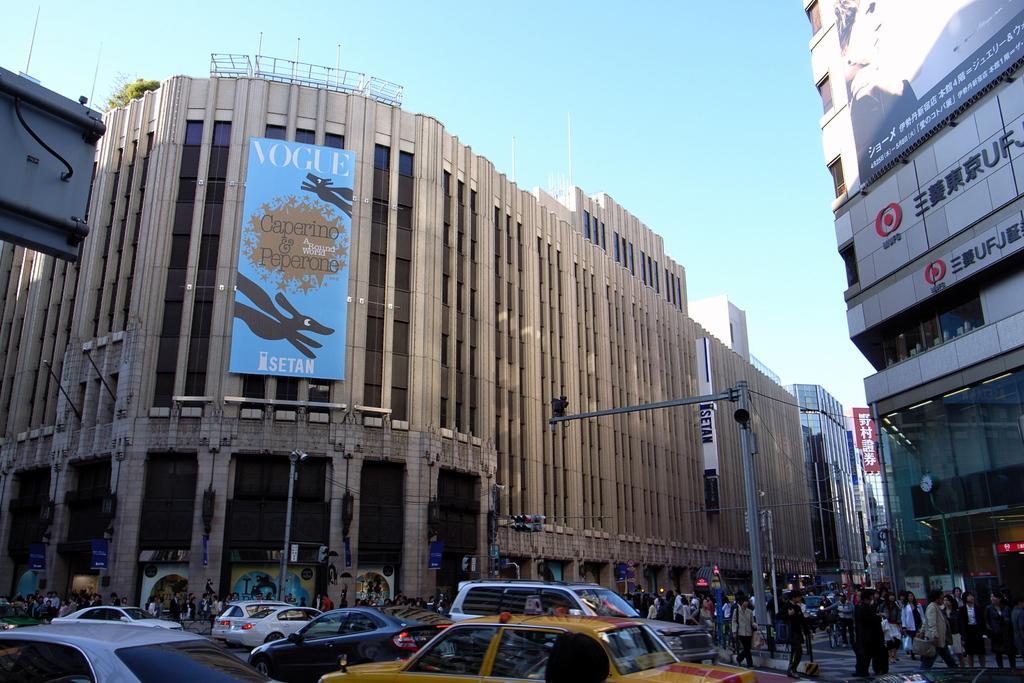Please provide a concise description of this image. In this image we can see so many people and cars on the road. Background of the image poles, wires and buildings are there. We can see banners are attached to the buildings. At the top of the image, sky is there. 